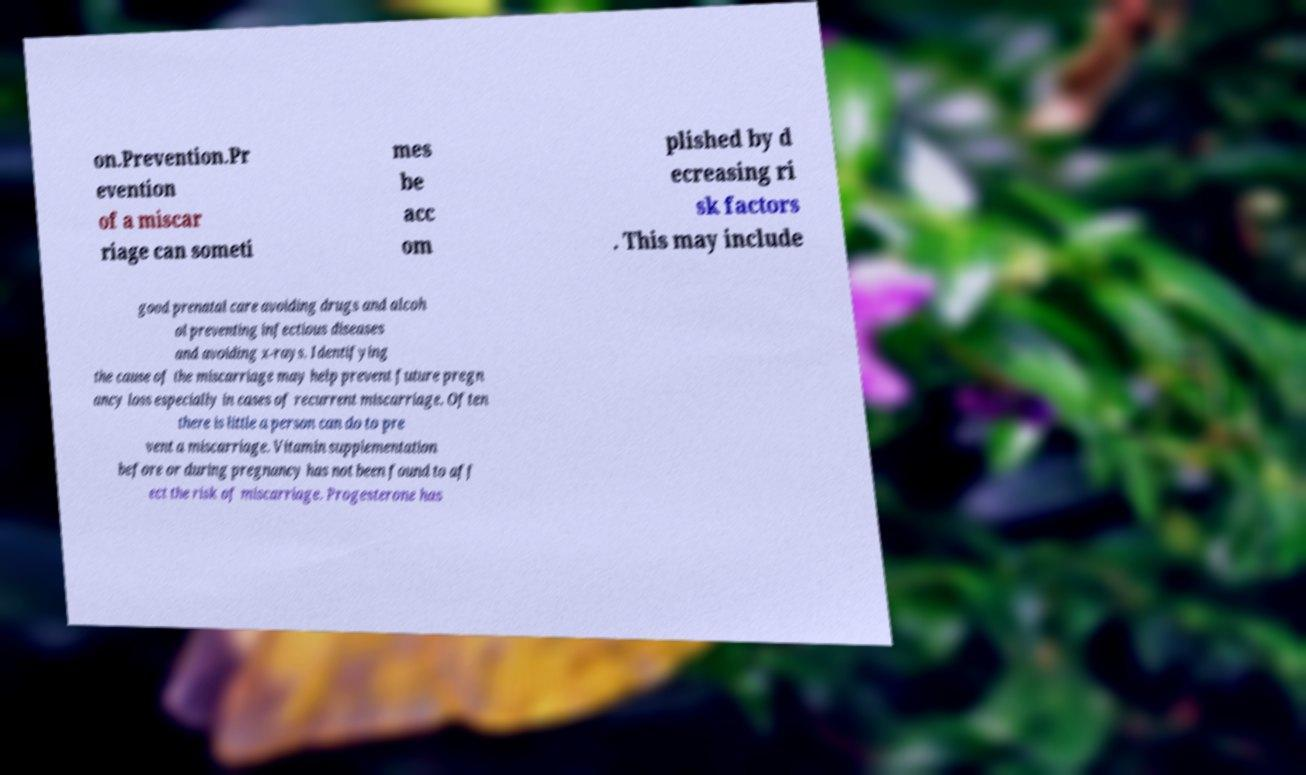Please identify and transcribe the text found in this image. on.Prevention.Pr evention of a miscar riage can someti mes be acc om plished by d ecreasing ri sk factors . This may include good prenatal care avoiding drugs and alcoh ol preventing infectious diseases and avoiding x-rays. Identifying the cause of the miscarriage may help prevent future pregn ancy loss especially in cases of recurrent miscarriage. Often there is little a person can do to pre vent a miscarriage. Vitamin supplementation before or during pregnancy has not been found to aff ect the risk of miscarriage. Progesterone has 